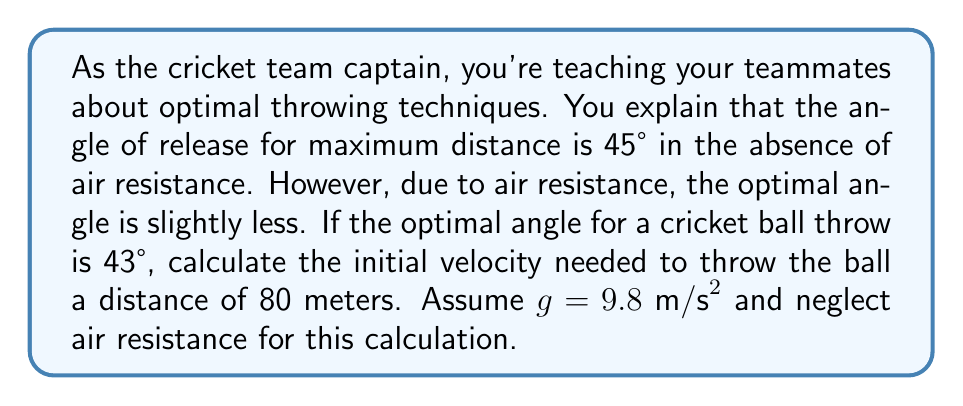Provide a solution to this math problem. Let's approach this step-by-step:

1) The equation for the range (R) of a projectile launched at an angle θ with initial velocity v is:

   $$R = \frac{v^2 \sin(2θ)}{g}$$

2) We're given:
   - R = 80 meters
   - θ = 43° = 43 * π/180 radians
   - g = 9.8 m/s²

3) Let's substitute these into our equation:

   $$80 = \frac{v^2 \sin(2 * 43 * π/180)}{9.8}$$

4) Simplify the sine term:
   $$\sin(2 * 43 * π/180) ≈ 0.9976$$

5) Now our equation looks like:

   $$80 = \frac{v^2 * 0.9976}{9.8}$$

6) Multiply both sides by 9.8:

   $$784 = v^2 * 0.9976$$

7) Divide both sides by 0.9976:

   $$785.88 = v^2$$

8) Take the square root of both sides:

   $$v = \sqrt{785.88} ≈ 28.03 \text{ m/s}$$

Therefore, the initial velocity needed is approximately 28.03 m/s.
Answer: The initial velocity needed to throw the cricket ball 80 meters at a 43° angle is approximately 28.03 m/s. 